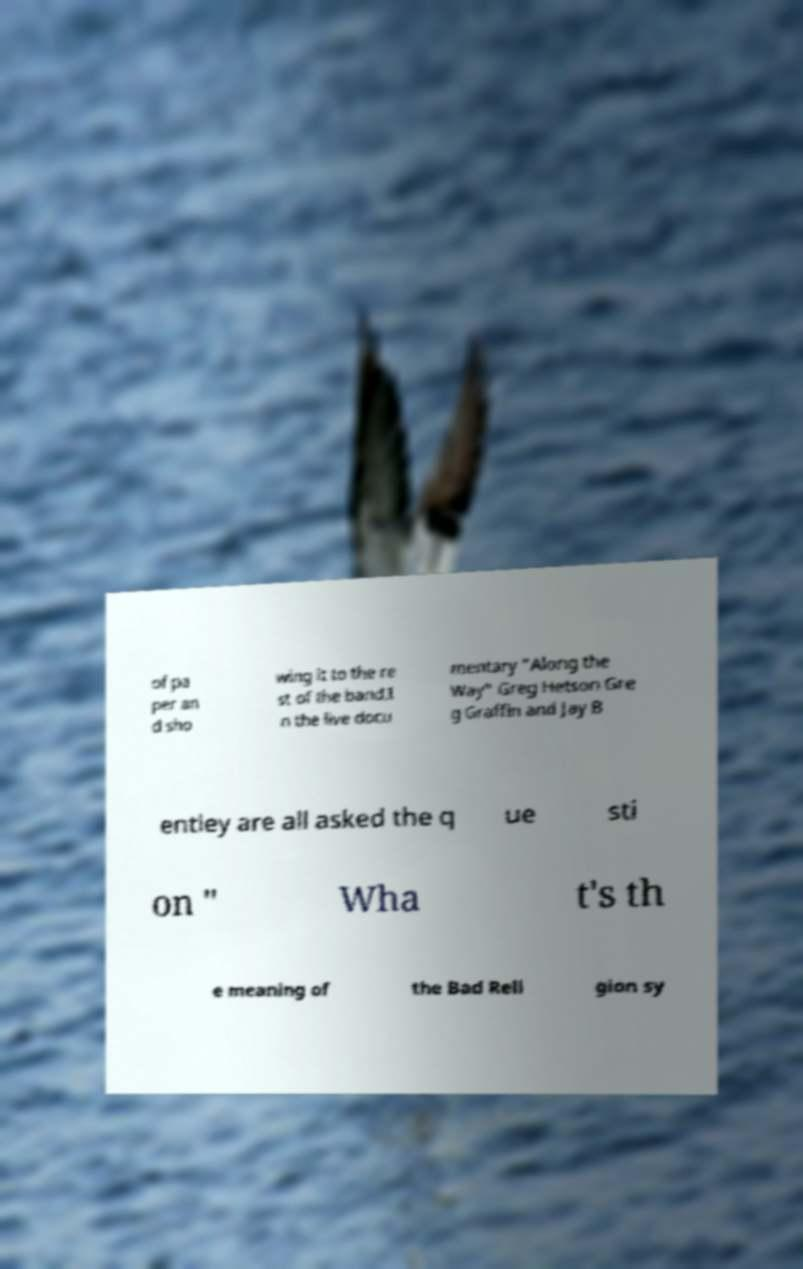I need the written content from this picture converted into text. Can you do that? of pa per an d sho wing it to the re st of the band.I n the live docu mentary "Along the Way" Greg Hetson Gre g Graffin and Jay B entley are all asked the q ue sti on " Wha t's th e meaning of the Bad Reli gion sy 